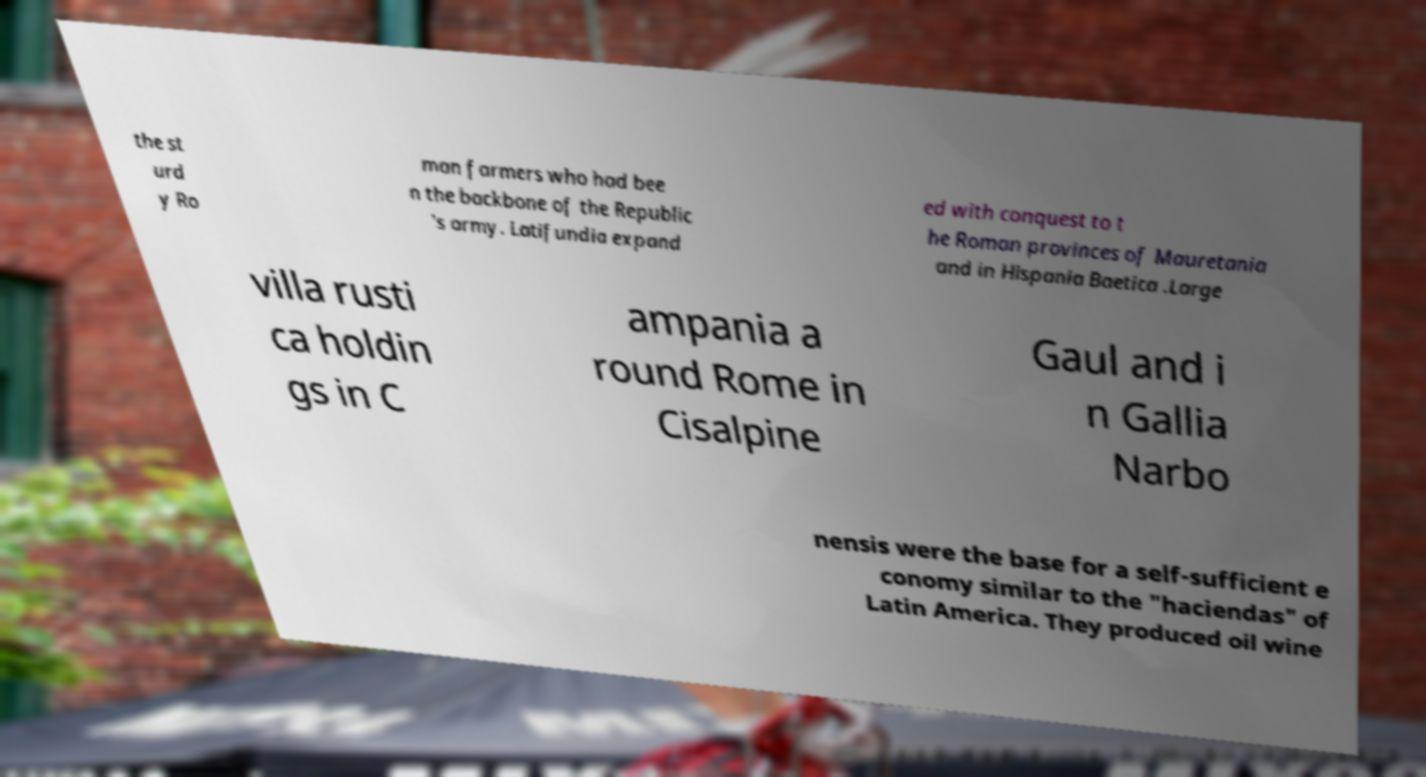Could you extract and type out the text from this image? the st urd y Ro man farmers who had bee n the backbone of the Republic 's army. Latifundia expand ed with conquest to t he Roman provinces of Mauretania and in Hispania Baetica .Large villa rusti ca holdin gs in C ampania a round Rome in Cisalpine Gaul and i n Gallia Narbo nensis were the base for a self-sufficient e conomy similar to the "haciendas" of Latin America. They produced oil wine 